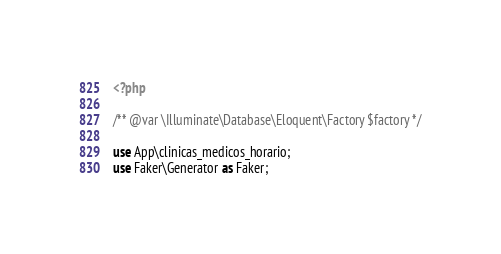<code> <loc_0><loc_0><loc_500><loc_500><_PHP_><?php

/** @var \Illuminate\Database\Eloquent\Factory $factory */

use App\clinicas_medicos_horario;
use Faker\Generator as Faker;
</code> 